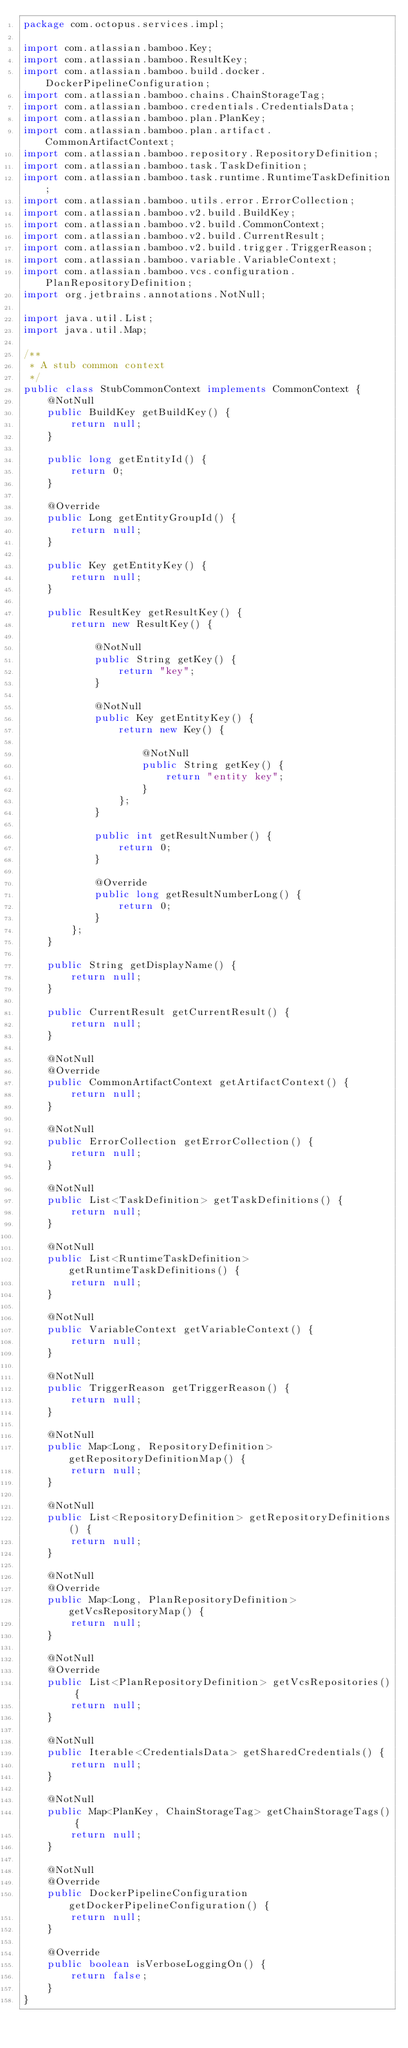<code> <loc_0><loc_0><loc_500><loc_500><_Java_>package com.octopus.services.impl;

import com.atlassian.bamboo.Key;
import com.atlassian.bamboo.ResultKey;
import com.atlassian.bamboo.build.docker.DockerPipelineConfiguration;
import com.atlassian.bamboo.chains.ChainStorageTag;
import com.atlassian.bamboo.credentials.CredentialsData;
import com.atlassian.bamboo.plan.PlanKey;
import com.atlassian.bamboo.plan.artifact.CommonArtifactContext;
import com.atlassian.bamboo.repository.RepositoryDefinition;
import com.atlassian.bamboo.task.TaskDefinition;
import com.atlassian.bamboo.task.runtime.RuntimeTaskDefinition;
import com.atlassian.bamboo.utils.error.ErrorCollection;
import com.atlassian.bamboo.v2.build.BuildKey;
import com.atlassian.bamboo.v2.build.CommonContext;
import com.atlassian.bamboo.v2.build.CurrentResult;
import com.atlassian.bamboo.v2.build.trigger.TriggerReason;
import com.atlassian.bamboo.variable.VariableContext;
import com.atlassian.bamboo.vcs.configuration.PlanRepositoryDefinition;
import org.jetbrains.annotations.NotNull;

import java.util.List;
import java.util.Map;

/**
 * A stub common context
 */
public class StubCommonContext implements CommonContext {
    @NotNull
    public BuildKey getBuildKey() {
        return null;
    }

    public long getEntityId() {
        return 0;
    }

    @Override
    public Long getEntityGroupId() {
        return null;
    }

    public Key getEntityKey() {
        return null;
    }

    public ResultKey getResultKey() {
        return new ResultKey() {

            @NotNull
            public String getKey() {
                return "key";
            }

            @NotNull
            public Key getEntityKey() {
                return new Key() {

                    @NotNull
                    public String getKey() {
                        return "entity key";
                    }
                };
            }

            public int getResultNumber() {
                return 0;
            }

            @Override
            public long getResultNumberLong() {
                return 0;
            }
        };
    }

    public String getDisplayName() {
        return null;
    }

    public CurrentResult getCurrentResult() {
        return null;
    }

    @NotNull
    @Override
    public CommonArtifactContext getArtifactContext() {
        return null;
    }

    @NotNull
    public ErrorCollection getErrorCollection() {
        return null;
    }

    @NotNull
    public List<TaskDefinition> getTaskDefinitions() {
        return null;
    }

    @NotNull
    public List<RuntimeTaskDefinition> getRuntimeTaskDefinitions() {
        return null;
    }

    @NotNull
    public VariableContext getVariableContext() {
        return null;
    }

    @NotNull
    public TriggerReason getTriggerReason() {
        return null;
    }

    @NotNull
    public Map<Long, RepositoryDefinition> getRepositoryDefinitionMap() {
        return null;
    }

    @NotNull
    public List<RepositoryDefinition> getRepositoryDefinitions() {
        return null;
    }

    @NotNull
    @Override
    public Map<Long, PlanRepositoryDefinition> getVcsRepositoryMap() {
        return null;
    }

    @NotNull
    @Override
    public List<PlanRepositoryDefinition> getVcsRepositories() {
        return null;
    }

    @NotNull
    public Iterable<CredentialsData> getSharedCredentials() {
        return null;
    }

    @NotNull
    public Map<PlanKey, ChainStorageTag> getChainStorageTags() {
        return null;
    }

    @NotNull
    @Override
    public DockerPipelineConfiguration getDockerPipelineConfiguration() {
        return null;
    }

    @Override
    public boolean isVerboseLoggingOn() {
        return false;
    }
}
</code> 